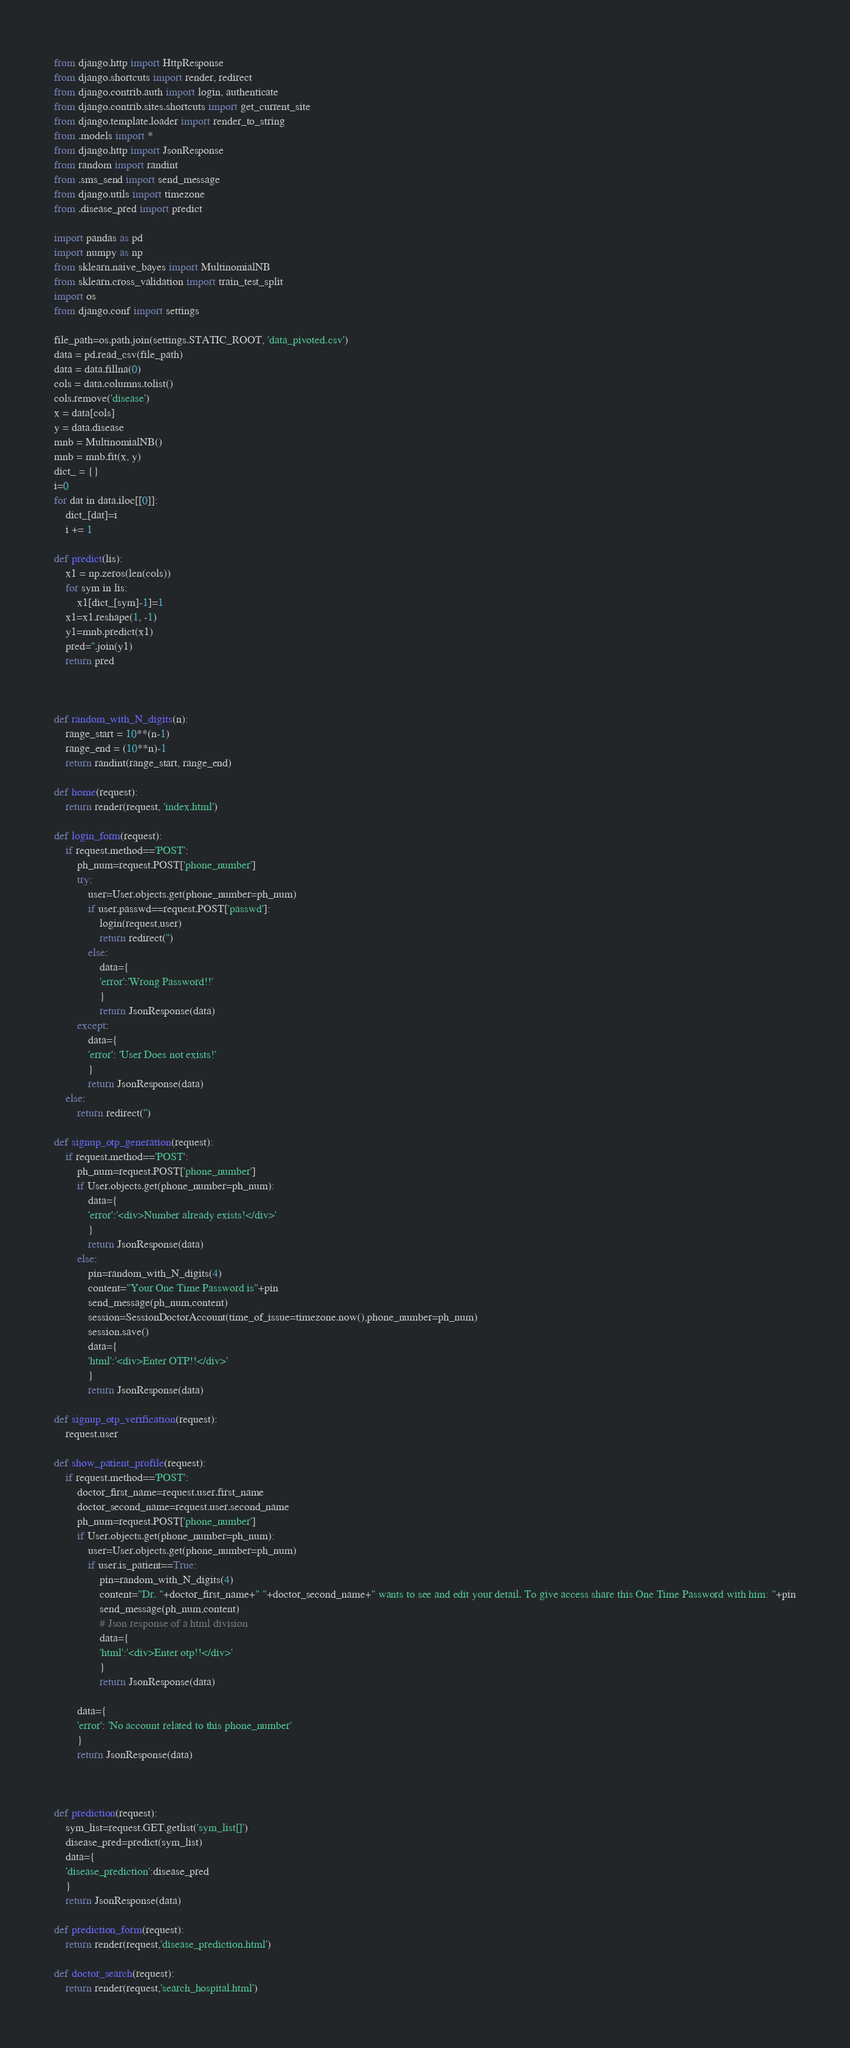Convert code to text. <code><loc_0><loc_0><loc_500><loc_500><_Python_>from django.http import HttpResponse
from django.shortcuts import render, redirect
from django.contrib.auth import login, authenticate
from django.contrib.sites.shortcuts import get_current_site
from django.template.loader import render_to_string
from .models import *
from django.http import JsonResponse
from random import randint
from .sms_send import send_message
from django.utils import timezone
from .disease_pred import predict

import pandas as pd
import numpy as np
from sklearn.naive_bayes import MultinomialNB
from sklearn.cross_validation import train_test_split
import os
from django.conf import settings

file_path=os.path.join(settings.STATIC_ROOT, 'data_pivoted.csv')
data = pd.read_csv(file_path)
data = data.fillna(0)
cols = data.columns.tolist()
cols.remove('disease')
x = data[cols]
y = data.disease
mnb = MultinomialNB()
mnb = mnb.fit(x, y)
dict_ = {}
i=0
for dat in data.iloc[[0]]:
	dict_[dat]=i
	i += 1

def predict(lis):	
	x1 = np.zeros(len(cols))
	for sym in lis:
		x1[dict_[sym]-1]=1
	x1=x1.reshape(1, -1)
	y1=mnb.predict(x1)
	pred=''.join(y1)
	return pred



def random_with_N_digits(n):
    range_start = 10**(n-1)
    range_end = (10**n)-1
    return randint(range_start, range_end)

def home(request):
	return render(request, 'index.html')

def login_form(request):
	if request.method=='POST':
		ph_num=request.POST['phone_number']
		try:
			user=User.objects.get(phone_number=ph_num)
			if user.passwd==request.POST['passwd']:
				login(request,user)
				return redirect('')
			else:
				data={
				'error':'Wrong Password!!'
				}
				return JsonResponse(data)
		except:
			data={
			'error': 'User Does not exists!'
			}
			return JsonResponse(data)
	else:
		return redirect('')

def signup_otp_generation(request):
	if request.method=='POST':
		ph_num=request.POST['phone_number']
		if User.objects.get(phone_number=ph_num):
			data={
			'error':'<div>Number already exists!</div>'
			}
			return JsonResponse(data)
		else:
			pin=random_with_N_digits(4)
			content="Your One Time Password is"+pin
			send_message(ph_num,content)
			session=SessionDoctorAccount(time_of_issue=timezone.now(),phone_number=ph_num)
			session.save()
			data={
			'html':'<div>Enter OTP!!</div>'
			}
			return JsonResponse(data)

def signup_otp_verification(request):
	request.user

def show_patient_profile(request):
	if request.method=='POST':
		doctor_first_name=request.user.first_name
		doctor_second_name=request.user.second_name
		ph_num=request.POST['phone_number']
		if User.objects.get(phone_number=ph_num):
			user=User.objects.get(phone_number=ph_num)
			if user.is_patient==True:
				pin=random_with_N_digits(4)
				content="Dr. "+doctor_first_name+" "+doctor_second_name+" wants to see and edit your detail. To give access share this One Time Password with him: "+pin
				send_message(ph_num,content)
				# Json response of a html division
				data={
				'html':'<div>Enter otp!!</div>'
				}
				return JsonResponse(data)

		data={
		'error': 'No account related to this phone_number'
		}
		return JsonResponse(data)



def prediction(request):
	sym_list=request.GET.getlist('sym_list[]')
	disease_pred=predict(sym_list)
	data={
	'disease_prediction':disease_pred
	}
	return JsonResponse(data)

def prediction_form(request):
	return render(request,'disease_prediction.html')

def doctor_search(request):
	return render(request,'search_hospital.html')</code> 